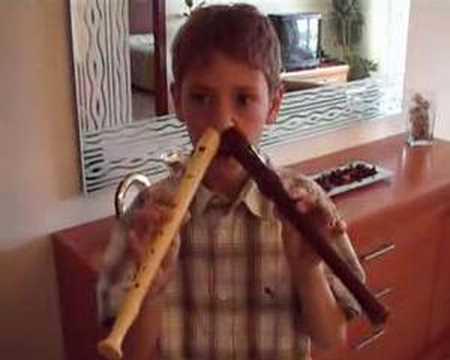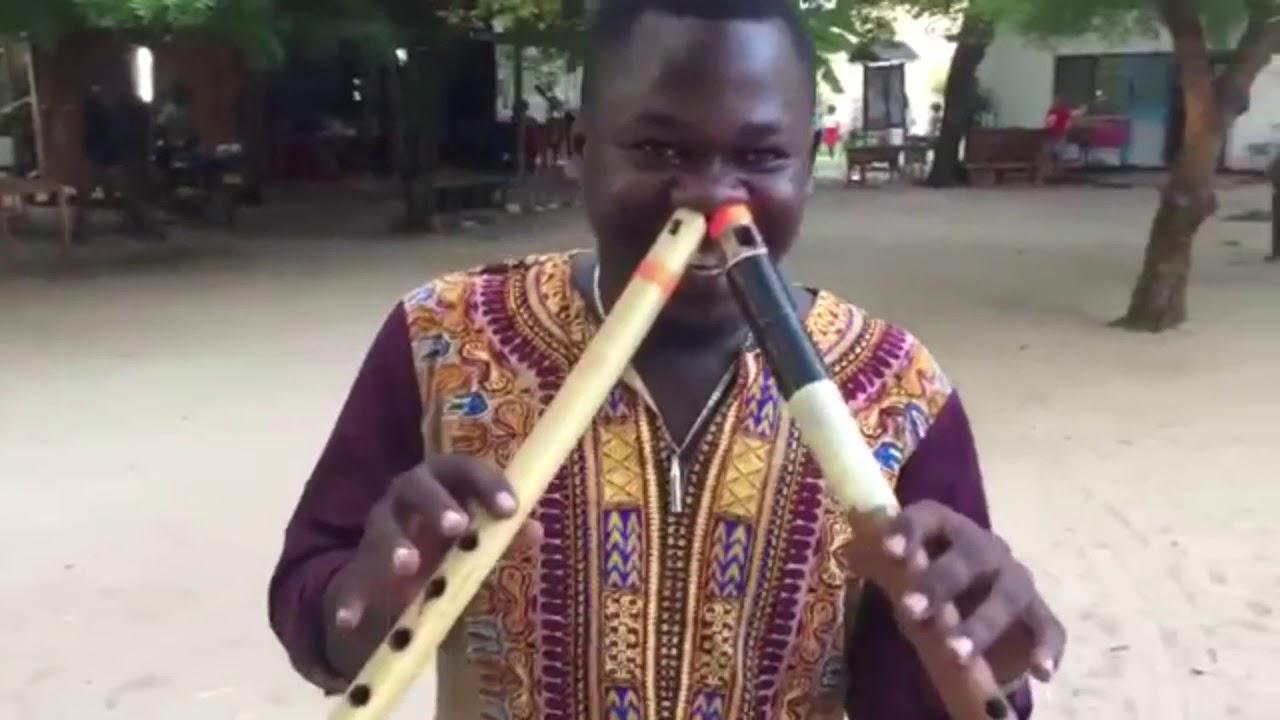The first image is the image on the left, the second image is the image on the right. Considering the images on both sides, is "Each musician is holding two instruments." valid? Answer yes or no. Yes. The first image is the image on the left, the second image is the image on the right. Given the left and right images, does the statement "In the right image, a male is holding two flute-like instruments to his mouth so they form a V-shape." hold true? Answer yes or no. No. 